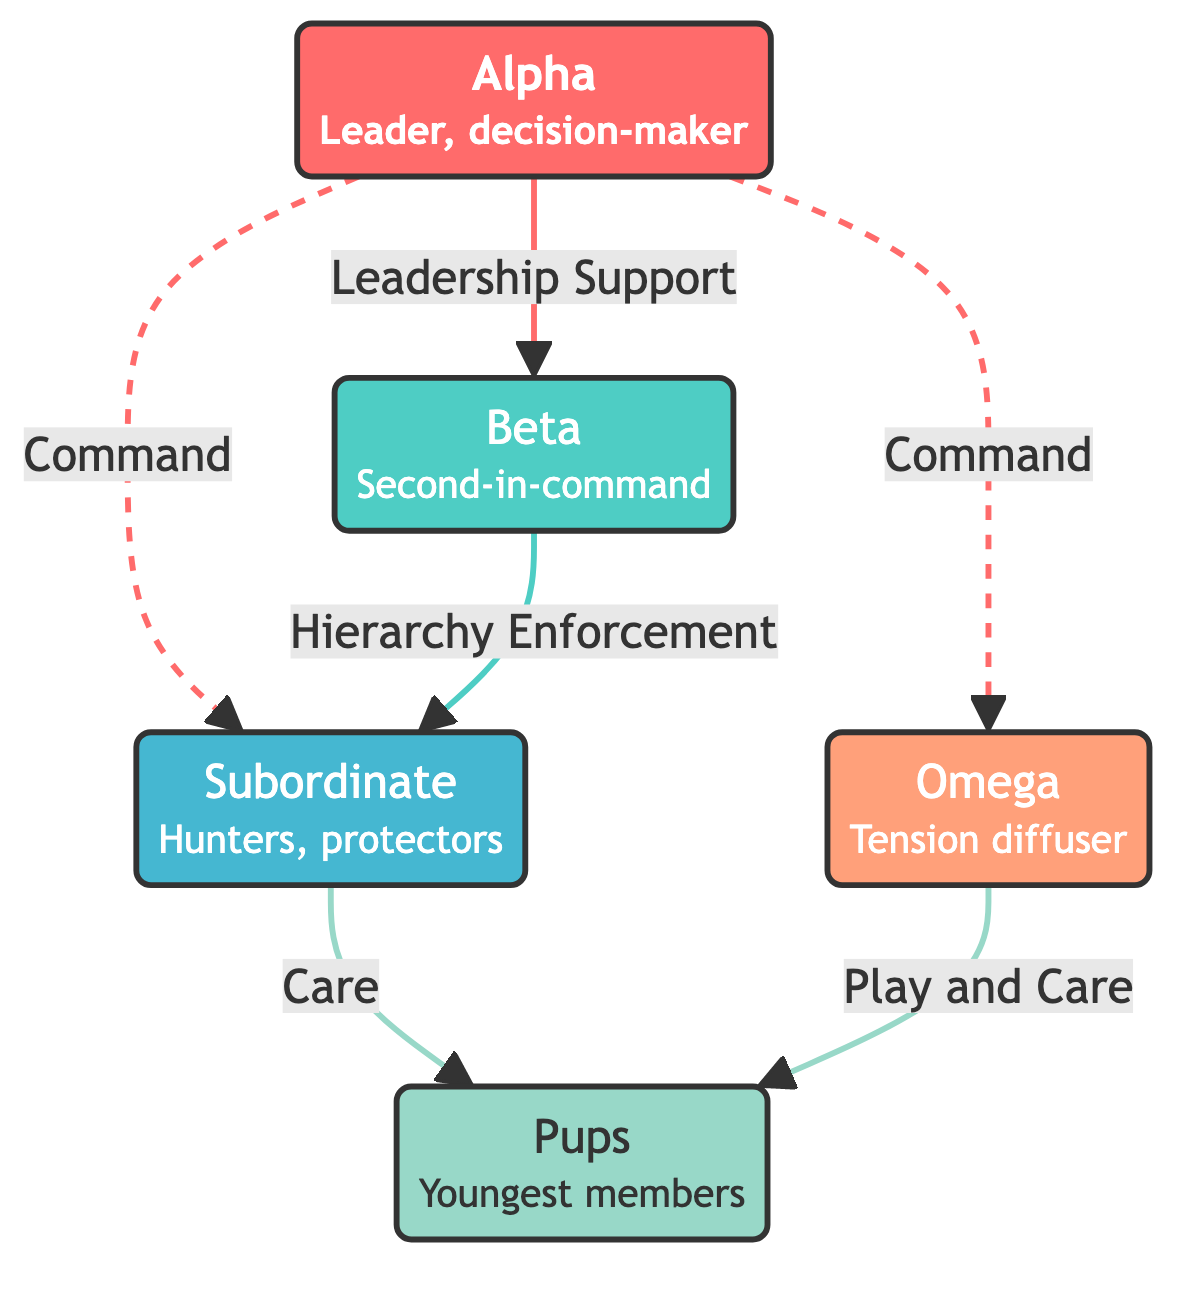What is the role of the Alpha in the pack? The Alpha is responsible for decision-making and maintaining order in the pack, as indicated in the node description.
Answer: Leader, decision-maker How many nodes are present in the diagram? The diagram lists five nodes: Alpha, Beta, Subordinate, Omega, and Pups, all of which are distinct members of the pack hierarchy.
Answer: 5 What relationship exists between Alpha and Beta? The diagram shows a direct edge labeled "Leadership Support," indicating that the Alpha provides support to Beta in their role.
Answer: Leadership Support Which member is at the lowest rank in the pack hierarchy? The Omega is described as the lowest-ranking member, responsible for diffusing tension, as specified in the node description for Omega.
Answer: Omega What is the connection between Subordinates and Pups? There is a direct edge labeled "Care" from Subordinate to Pups in the diagram, highlighting the Subordinates' role in caring for the Pups.
Answer: Care How many edges connect to the Alpha node? Three edges originate from the Alpha node, connecting it to Beta, Subordinate, and Omega, indicating its command over these members.
Answer: 3 What role does the Omega play in relation to the Pups? The Omega is responsible for both playing and caring for the Pups, as indicated by the edge labeled "Play and Care" going from Omega to Pups.
Answer: Play and Care Which two members have a direct relationship involving care? The diagram shows a relationship of care from Subordinate to Pups, as well as from Omega to Pups, indicating multiple members share this responsibility.
Answer: Subordinate, Omega What type of diagram is this? The structure of the diagram is a Network Diagram, as it depicts relationships and roles among different members of the wolf pack.
Answer: Network Diagram 